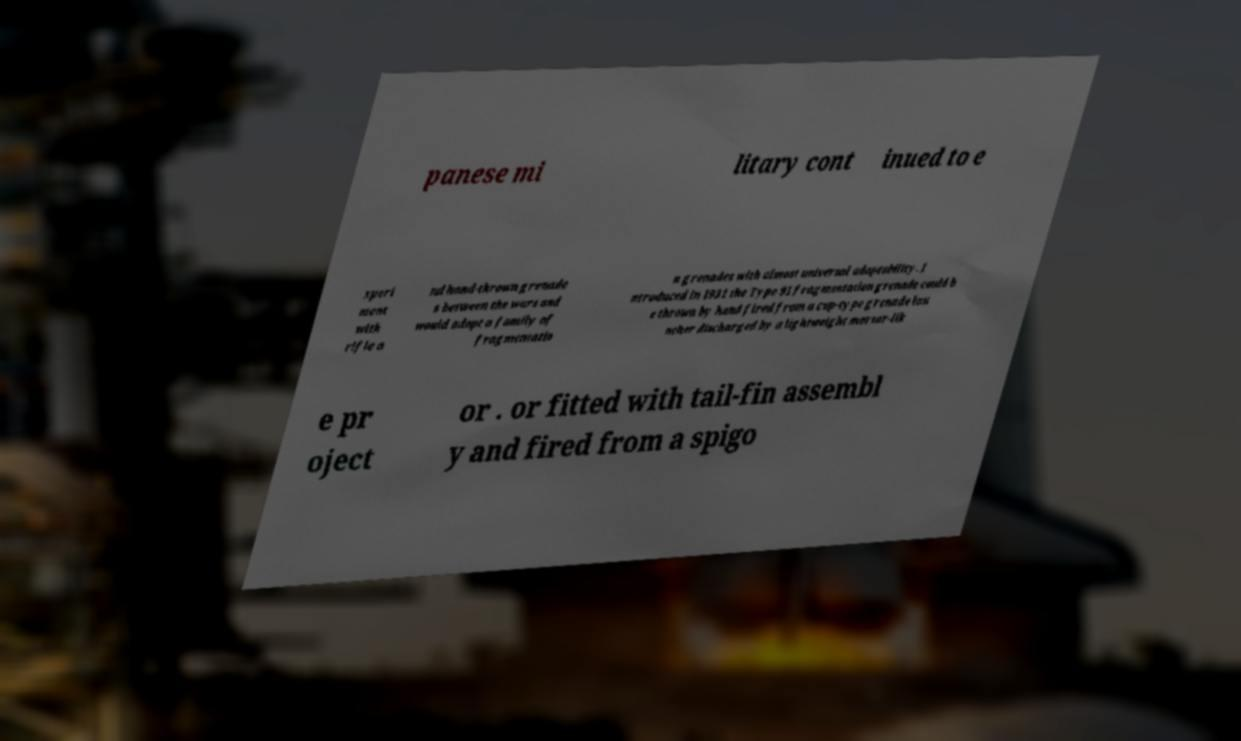Please identify and transcribe the text found in this image. panese mi litary cont inued to e xperi ment with rifle a nd hand-thrown grenade s between the wars and would adopt a family of fragmentatio n grenades with almost universal adaptability. I ntroduced in 1931 the Type 91 fragmentation grenade could b e thrown by hand fired from a cup-type grenade lau ncher discharged by a lightweight mortar-lik e pr oject or . or fitted with tail-fin assembl y and fired from a spigo 